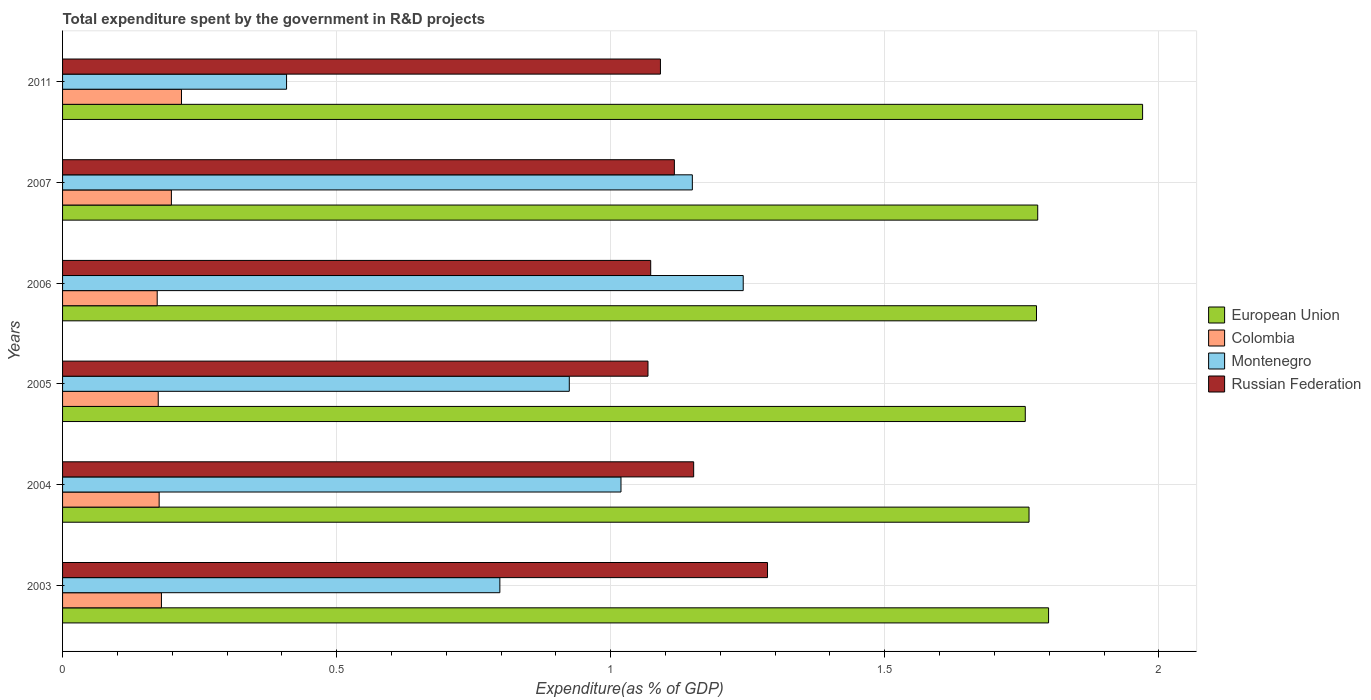How many groups of bars are there?
Keep it short and to the point. 6. Are the number of bars per tick equal to the number of legend labels?
Ensure brevity in your answer.  Yes. Are the number of bars on each tick of the Y-axis equal?
Provide a short and direct response. Yes. How many bars are there on the 6th tick from the top?
Offer a very short reply. 4. How many bars are there on the 3rd tick from the bottom?
Keep it short and to the point. 4. What is the label of the 5th group of bars from the top?
Your answer should be compact. 2004. In how many cases, is the number of bars for a given year not equal to the number of legend labels?
Provide a succinct answer. 0. What is the total expenditure spent by the government in R&D projects in Colombia in 2004?
Provide a succinct answer. 0.18. Across all years, what is the maximum total expenditure spent by the government in R&D projects in Montenegro?
Offer a very short reply. 1.24. Across all years, what is the minimum total expenditure spent by the government in R&D projects in Colombia?
Ensure brevity in your answer.  0.17. In which year was the total expenditure spent by the government in R&D projects in Montenegro maximum?
Give a very brief answer. 2006. In which year was the total expenditure spent by the government in R&D projects in Colombia minimum?
Provide a succinct answer. 2006. What is the total total expenditure spent by the government in R&D projects in Montenegro in the graph?
Your answer should be very brief. 5.54. What is the difference between the total expenditure spent by the government in R&D projects in Montenegro in 2007 and that in 2011?
Ensure brevity in your answer.  0.74. What is the difference between the total expenditure spent by the government in R&D projects in Montenegro in 2007 and the total expenditure spent by the government in R&D projects in European Union in 2003?
Ensure brevity in your answer.  -0.65. What is the average total expenditure spent by the government in R&D projects in Russian Federation per year?
Provide a short and direct response. 1.13. In the year 2005, what is the difference between the total expenditure spent by the government in R&D projects in European Union and total expenditure spent by the government in R&D projects in Russian Federation?
Keep it short and to the point. 0.69. In how many years, is the total expenditure spent by the government in R&D projects in European Union greater than 0.30000000000000004 %?
Make the answer very short. 6. What is the ratio of the total expenditure spent by the government in R&D projects in Colombia in 2005 to that in 2011?
Your response must be concise. 0.8. What is the difference between the highest and the second highest total expenditure spent by the government in R&D projects in Russian Federation?
Offer a terse response. 0.13. What is the difference between the highest and the lowest total expenditure spent by the government in R&D projects in Russian Federation?
Offer a terse response. 0.22. In how many years, is the total expenditure spent by the government in R&D projects in Russian Federation greater than the average total expenditure spent by the government in R&D projects in Russian Federation taken over all years?
Give a very brief answer. 2. Is it the case that in every year, the sum of the total expenditure spent by the government in R&D projects in Colombia and total expenditure spent by the government in R&D projects in European Union is greater than the sum of total expenditure spent by the government in R&D projects in Russian Federation and total expenditure spent by the government in R&D projects in Montenegro?
Ensure brevity in your answer.  No. What does the 1st bar from the top in 2005 represents?
Make the answer very short. Russian Federation. How many bars are there?
Offer a very short reply. 24. How many years are there in the graph?
Make the answer very short. 6. Does the graph contain grids?
Your answer should be very brief. Yes. What is the title of the graph?
Keep it short and to the point. Total expenditure spent by the government in R&D projects. Does "High income" appear as one of the legend labels in the graph?
Your answer should be compact. No. What is the label or title of the X-axis?
Make the answer very short. Expenditure(as % of GDP). What is the label or title of the Y-axis?
Keep it short and to the point. Years. What is the Expenditure(as % of GDP) in European Union in 2003?
Make the answer very short. 1.8. What is the Expenditure(as % of GDP) in Colombia in 2003?
Your answer should be compact. 0.18. What is the Expenditure(as % of GDP) of Montenegro in 2003?
Provide a succinct answer. 0.8. What is the Expenditure(as % of GDP) of Russian Federation in 2003?
Offer a terse response. 1.29. What is the Expenditure(as % of GDP) of European Union in 2004?
Offer a terse response. 1.76. What is the Expenditure(as % of GDP) of Colombia in 2004?
Your answer should be compact. 0.18. What is the Expenditure(as % of GDP) of Montenegro in 2004?
Make the answer very short. 1.02. What is the Expenditure(as % of GDP) in Russian Federation in 2004?
Your answer should be very brief. 1.15. What is the Expenditure(as % of GDP) of European Union in 2005?
Your answer should be very brief. 1.76. What is the Expenditure(as % of GDP) of Colombia in 2005?
Make the answer very short. 0.17. What is the Expenditure(as % of GDP) in Montenegro in 2005?
Give a very brief answer. 0.92. What is the Expenditure(as % of GDP) in Russian Federation in 2005?
Make the answer very short. 1.07. What is the Expenditure(as % of GDP) of European Union in 2006?
Your response must be concise. 1.78. What is the Expenditure(as % of GDP) in Colombia in 2006?
Give a very brief answer. 0.17. What is the Expenditure(as % of GDP) in Montenegro in 2006?
Give a very brief answer. 1.24. What is the Expenditure(as % of GDP) in Russian Federation in 2006?
Your answer should be very brief. 1.07. What is the Expenditure(as % of GDP) in European Union in 2007?
Your response must be concise. 1.78. What is the Expenditure(as % of GDP) of Colombia in 2007?
Provide a succinct answer. 0.2. What is the Expenditure(as % of GDP) of Montenegro in 2007?
Your answer should be compact. 1.15. What is the Expenditure(as % of GDP) in Russian Federation in 2007?
Your answer should be compact. 1.12. What is the Expenditure(as % of GDP) of European Union in 2011?
Your answer should be very brief. 1.97. What is the Expenditure(as % of GDP) in Colombia in 2011?
Provide a succinct answer. 0.22. What is the Expenditure(as % of GDP) of Montenegro in 2011?
Ensure brevity in your answer.  0.41. What is the Expenditure(as % of GDP) of Russian Federation in 2011?
Your response must be concise. 1.09. Across all years, what is the maximum Expenditure(as % of GDP) in European Union?
Give a very brief answer. 1.97. Across all years, what is the maximum Expenditure(as % of GDP) of Colombia?
Make the answer very short. 0.22. Across all years, what is the maximum Expenditure(as % of GDP) in Montenegro?
Provide a short and direct response. 1.24. Across all years, what is the maximum Expenditure(as % of GDP) of Russian Federation?
Keep it short and to the point. 1.29. Across all years, what is the minimum Expenditure(as % of GDP) in European Union?
Provide a short and direct response. 1.76. Across all years, what is the minimum Expenditure(as % of GDP) in Colombia?
Provide a short and direct response. 0.17. Across all years, what is the minimum Expenditure(as % of GDP) of Montenegro?
Provide a short and direct response. 0.41. Across all years, what is the minimum Expenditure(as % of GDP) of Russian Federation?
Provide a short and direct response. 1.07. What is the total Expenditure(as % of GDP) in European Union in the graph?
Provide a succinct answer. 10.84. What is the total Expenditure(as % of GDP) in Colombia in the graph?
Your answer should be very brief. 1.12. What is the total Expenditure(as % of GDP) in Montenegro in the graph?
Keep it short and to the point. 5.54. What is the total Expenditure(as % of GDP) in Russian Federation in the graph?
Your answer should be compact. 6.79. What is the difference between the Expenditure(as % of GDP) in European Union in 2003 and that in 2004?
Provide a succinct answer. 0.04. What is the difference between the Expenditure(as % of GDP) in Colombia in 2003 and that in 2004?
Offer a very short reply. 0. What is the difference between the Expenditure(as % of GDP) in Montenegro in 2003 and that in 2004?
Your answer should be compact. -0.22. What is the difference between the Expenditure(as % of GDP) in Russian Federation in 2003 and that in 2004?
Your response must be concise. 0.13. What is the difference between the Expenditure(as % of GDP) in European Union in 2003 and that in 2005?
Provide a short and direct response. 0.04. What is the difference between the Expenditure(as % of GDP) in Colombia in 2003 and that in 2005?
Provide a succinct answer. 0.01. What is the difference between the Expenditure(as % of GDP) in Montenegro in 2003 and that in 2005?
Keep it short and to the point. -0.13. What is the difference between the Expenditure(as % of GDP) of Russian Federation in 2003 and that in 2005?
Your answer should be compact. 0.22. What is the difference between the Expenditure(as % of GDP) in European Union in 2003 and that in 2006?
Your answer should be very brief. 0.02. What is the difference between the Expenditure(as % of GDP) of Colombia in 2003 and that in 2006?
Provide a short and direct response. 0.01. What is the difference between the Expenditure(as % of GDP) of Montenegro in 2003 and that in 2006?
Offer a terse response. -0.44. What is the difference between the Expenditure(as % of GDP) in Russian Federation in 2003 and that in 2006?
Your answer should be compact. 0.21. What is the difference between the Expenditure(as % of GDP) in European Union in 2003 and that in 2007?
Keep it short and to the point. 0.02. What is the difference between the Expenditure(as % of GDP) of Colombia in 2003 and that in 2007?
Give a very brief answer. -0.02. What is the difference between the Expenditure(as % of GDP) in Montenegro in 2003 and that in 2007?
Your answer should be very brief. -0.35. What is the difference between the Expenditure(as % of GDP) in Russian Federation in 2003 and that in 2007?
Make the answer very short. 0.17. What is the difference between the Expenditure(as % of GDP) of European Union in 2003 and that in 2011?
Provide a short and direct response. -0.17. What is the difference between the Expenditure(as % of GDP) of Colombia in 2003 and that in 2011?
Your response must be concise. -0.04. What is the difference between the Expenditure(as % of GDP) of Montenegro in 2003 and that in 2011?
Provide a succinct answer. 0.39. What is the difference between the Expenditure(as % of GDP) of Russian Federation in 2003 and that in 2011?
Your response must be concise. 0.2. What is the difference between the Expenditure(as % of GDP) in European Union in 2004 and that in 2005?
Your answer should be very brief. 0.01. What is the difference between the Expenditure(as % of GDP) of Colombia in 2004 and that in 2005?
Provide a succinct answer. 0. What is the difference between the Expenditure(as % of GDP) of Montenegro in 2004 and that in 2005?
Ensure brevity in your answer.  0.09. What is the difference between the Expenditure(as % of GDP) of Russian Federation in 2004 and that in 2005?
Give a very brief answer. 0.08. What is the difference between the Expenditure(as % of GDP) of European Union in 2004 and that in 2006?
Provide a short and direct response. -0.01. What is the difference between the Expenditure(as % of GDP) in Colombia in 2004 and that in 2006?
Make the answer very short. 0. What is the difference between the Expenditure(as % of GDP) in Montenegro in 2004 and that in 2006?
Make the answer very short. -0.22. What is the difference between the Expenditure(as % of GDP) in Russian Federation in 2004 and that in 2006?
Your response must be concise. 0.08. What is the difference between the Expenditure(as % of GDP) of European Union in 2004 and that in 2007?
Provide a succinct answer. -0.02. What is the difference between the Expenditure(as % of GDP) of Colombia in 2004 and that in 2007?
Ensure brevity in your answer.  -0.02. What is the difference between the Expenditure(as % of GDP) in Montenegro in 2004 and that in 2007?
Make the answer very short. -0.13. What is the difference between the Expenditure(as % of GDP) in Russian Federation in 2004 and that in 2007?
Ensure brevity in your answer.  0.04. What is the difference between the Expenditure(as % of GDP) of European Union in 2004 and that in 2011?
Provide a short and direct response. -0.21. What is the difference between the Expenditure(as % of GDP) of Colombia in 2004 and that in 2011?
Keep it short and to the point. -0.04. What is the difference between the Expenditure(as % of GDP) in Montenegro in 2004 and that in 2011?
Ensure brevity in your answer.  0.61. What is the difference between the Expenditure(as % of GDP) in Russian Federation in 2004 and that in 2011?
Keep it short and to the point. 0.06. What is the difference between the Expenditure(as % of GDP) of European Union in 2005 and that in 2006?
Give a very brief answer. -0.02. What is the difference between the Expenditure(as % of GDP) in Colombia in 2005 and that in 2006?
Provide a short and direct response. 0. What is the difference between the Expenditure(as % of GDP) of Montenegro in 2005 and that in 2006?
Offer a very short reply. -0.32. What is the difference between the Expenditure(as % of GDP) of Russian Federation in 2005 and that in 2006?
Your response must be concise. -0.01. What is the difference between the Expenditure(as % of GDP) of European Union in 2005 and that in 2007?
Your answer should be very brief. -0.02. What is the difference between the Expenditure(as % of GDP) in Colombia in 2005 and that in 2007?
Provide a short and direct response. -0.02. What is the difference between the Expenditure(as % of GDP) in Montenegro in 2005 and that in 2007?
Offer a terse response. -0.22. What is the difference between the Expenditure(as % of GDP) in Russian Federation in 2005 and that in 2007?
Offer a terse response. -0.05. What is the difference between the Expenditure(as % of GDP) of European Union in 2005 and that in 2011?
Make the answer very short. -0.21. What is the difference between the Expenditure(as % of GDP) in Colombia in 2005 and that in 2011?
Provide a succinct answer. -0.04. What is the difference between the Expenditure(as % of GDP) in Montenegro in 2005 and that in 2011?
Offer a terse response. 0.52. What is the difference between the Expenditure(as % of GDP) of Russian Federation in 2005 and that in 2011?
Your answer should be compact. -0.02. What is the difference between the Expenditure(as % of GDP) of European Union in 2006 and that in 2007?
Offer a terse response. -0. What is the difference between the Expenditure(as % of GDP) in Colombia in 2006 and that in 2007?
Provide a succinct answer. -0.03. What is the difference between the Expenditure(as % of GDP) of Montenegro in 2006 and that in 2007?
Provide a short and direct response. 0.09. What is the difference between the Expenditure(as % of GDP) of Russian Federation in 2006 and that in 2007?
Make the answer very short. -0.04. What is the difference between the Expenditure(as % of GDP) in European Union in 2006 and that in 2011?
Give a very brief answer. -0.19. What is the difference between the Expenditure(as % of GDP) of Colombia in 2006 and that in 2011?
Give a very brief answer. -0.04. What is the difference between the Expenditure(as % of GDP) of Montenegro in 2006 and that in 2011?
Ensure brevity in your answer.  0.83. What is the difference between the Expenditure(as % of GDP) in Russian Federation in 2006 and that in 2011?
Give a very brief answer. -0.02. What is the difference between the Expenditure(as % of GDP) in European Union in 2007 and that in 2011?
Your answer should be compact. -0.19. What is the difference between the Expenditure(as % of GDP) of Colombia in 2007 and that in 2011?
Keep it short and to the point. -0.02. What is the difference between the Expenditure(as % of GDP) in Montenegro in 2007 and that in 2011?
Ensure brevity in your answer.  0.74. What is the difference between the Expenditure(as % of GDP) of Russian Federation in 2007 and that in 2011?
Provide a short and direct response. 0.03. What is the difference between the Expenditure(as % of GDP) of European Union in 2003 and the Expenditure(as % of GDP) of Colombia in 2004?
Offer a very short reply. 1.62. What is the difference between the Expenditure(as % of GDP) of European Union in 2003 and the Expenditure(as % of GDP) of Montenegro in 2004?
Your response must be concise. 0.78. What is the difference between the Expenditure(as % of GDP) in European Union in 2003 and the Expenditure(as % of GDP) in Russian Federation in 2004?
Keep it short and to the point. 0.65. What is the difference between the Expenditure(as % of GDP) in Colombia in 2003 and the Expenditure(as % of GDP) in Montenegro in 2004?
Keep it short and to the point. -0.84. What is the difference between the Expenditure(as % of GDP) of Colombia in 2003 and the Expenditure(as % of GDP) of Russian Federation in 2004?
Ensure brevity in your answer.  -0.97. What is the difference between the Expenditure(as % of GDP) of Montenegro in 2003 and the Expenditure(as % of GDP) of Russian Federation in 2004?
Ensure brevity in your answer.  -0.35. What is the difference between the Expenditure(as % of GDP) in European Union in 2003 and the Expenditure(as % of GDP) in Colombia in 2005?
Provide a short and direct response. 1.62. What is the difference between the Expenditure(as % of GDP) of European Union in 2003 and the Expenditure(as % of GDP) of Montenegro in 2005?
Your answer should be compact. 0.87. What is the difference between the Expenditure(as % of GDP) of European Union in 2003 and the Expenditure(as % of GDP) of Russian Federation in 2005?
Provide a short and direct response. 0.73. What is the difference between the Expenditure(as % of GDP) in Colombia in 2003 and the Expenditure(as % of GDP) in Montenegro in 2005?
Offer a terse response. -0.74. What is the difference between the Expenditure(as % of GDP) of Colombia in 2003 and the Expenditure(as % of GDP) of Russian Federation in 2005?
Offer a terse response. -0.89. What is the difference between the Expenditure(as % of GDP) of Montenegro in 2003 and the Expenditure(as % of GDP) of Russian Federation in 2005?
Offer a terse response. -0.27. What is the difference between the Expenditure(as % of GDP) in European Union in 2003 and the Expenditure(as % of GDP) in Colombia in 2006?
Offer a terse response. 1.63. What is the difference between the Expenditure(as % of GDP) of European Union in 2003 and the Expenditure(as % of GDP) of Montenegro in 2006?
Provide a succinct answer. 0.56. What is the difference between the Expenditure(as % of GDP) in European Union in 2003 and the Expenditure(as % of GDP) in Russian Federation in 2006?
Your answer should be very brief. 0.73. What is the difference between the Expenditure(as % of GDP) in Colombia in 2003 and the Expenditure(as % of GDP) in Montenegro in 2006?
Your response must be concise. -1.06. What is the difference between the Expenditure(as % of GDP) in Colombia in 2003 and the Expenditure(as % of GDP) in Russian Federation in 2006?
Ensure brevity in your answer.  -0.89. What is the difference between the Expenditure(as % of GDP) of Montenegro in 2003 and the Expenditure(as % of GDP) of Russian Federation in 2006?
Offer a very short reply. -0.28. What is the difference between the Expenditure(as % of GDP) in European Union in 2003 and the Expenditure(as % of GDP) in Colombia in 2007?
Offer a terse response. 1.6. What is the difference between the Expenditure(as % of GDP) of European Union in 2003 and the Expenditure(as % of GDP) of Montenegro in 2007?
Your answer should be very brief. 0.65. What is the difference between the Expenditure(as % of GDP) of European Union in 2003 and the Expenditure(as % of GDP) of Russian Federation in 2007?
Your answer should be very brief. 0.68. What is the difference between the Expenditure(as % of GDP) of Colombia in 2003 and the Expenditure(as % of GDP) of Montenegro in 2007?
Give a very brief answer. -0.97. What is the difference between the Expenditure(as % of GDP) in Colombia in 2003 and the Expenditure(as % of GDP) in Russian Federation in 2007?
Ensure brevity in your answer.  -0.94. What is the difference between the Expenditure(as % of GDP) of Montenegro in 2003 and the Expenditure(as % of GDP) of Russian Federation in 2007?
Offer a terse response. -0.32. What is the difference between the Expenditure(as % of GDP) of European Union in 2003 and the Expenditure(as % of GDP) of Colombia in 2011?
Provide a short and direct response. 1.58. What is the difference between the Expenditure(as % of GDP) in European Union in 2003 and the Expenditure(as % of GDP) in Montenegro in 2011?
Give a very brief answer. 1.39. What is the difference between the Expenditure(as % of GDP) in European Union in 2003 and the Expenditure(as % of GDP) in Russian Federation in 2011?
Keep it short and to the point. 0.71. What is the difference between the Expenditure(as % of GDP) of Colombia in 2003 and the Expenditure(as % of GDP) of Montenegro in 2011?
Give a very brief answer. -0.23. What is the difference between the Expenditure(as % of GDP) in Colombia in 2003 and the Expenditure(as % of GDP) in Russian Federation in 2011?
Provide a short and direct response. -0.91. What is the difference between the Expenditure(as % of GDP) in Montenegro in 2003 and the Expenditure(as % of GDP) in Russian Federation in 2011?
Provide a succinct answer. -0.29. What is the difference between the Expenditure(as % of GDP) of European Union in 2004 and the Expenditure(as % of GDP) of Colombia in 2005?
Provide a short and direct response. 1.59. What is the difference between the Expenditure(as % of GDP) of European Union in 2004 and the Expenditure(as % of GDP) of Montenegro in 2005?
Provide a succinct answer. 0.84. What is the difference between the Expenditure(as % of GDP) in European Union in 2004 and the Expenditure(as % of GDP) in Russian Federation in 2005?
Your answer should be very brief. 0.7. What is the difference between the Expenditure(as % of GDP) in Colombia in 2004 and the Expenditure(as % of GDP) in Montenegro in 2005?
Your response must be concise. -0.75. What is the difference between the Expenditure(as % of GDP) of Colombia in 2004 and the Expenditure(as % of GDP) of Russian Federation in 2005?
Provide a short and direct response. -0.89. What is the difference between the Expenditure(as % of GDP) in Montenegro in 2004 and the Expenditure(as % of GDP) in Russian Federation in 2005?
Your answer should be very brief. -0.05. What is the difference between the Expenditure(as % of GDP) of European Union in 2004 and the Expenditure(as % of GDP) of Colombia in 2006?
Your answer should be very brief. 1.59. What is the difference between the Expenditure(as % of GDP) of European Union in 2004 and the Expenditure(as % of GDP) of Montenegro in 2006?
Make the answer very short. 0.52. What is the difference between the Expenditure(as % of GDP) in European Union in 2004 and the Expenditure(as % of GDP) in Russian Federation in 2006?
Offer a very short reply. 0.69. What is the difference between the Expenditure(as % of GDP) in Colombia in 2004 and the Expenditure(as % of GDP) in Montenegro in 2006?
Ensure brevity in your answer.  -1.07. What is the difference between the Expenditure(as % of GDP) in Colombia in 2004 and the Expenditure(as % of GDP) in Russian Federation in 2006?
Provide a succinct answer. -0.9. What is the difference between the Expenditure(as % of GDP) of Montenegro in 2004 and the Expenditure(as % of GDP) of Russian Federation in 2006?
Your response must be concise. -0.05. What is the difference between the Expenditure(as % of GDP) of European Union in 2004 and the Expenditure(as % of GDP) of Colombia in 2007?
Give a very brief answer. 1.56. What is the difference between the Expenditure(as % of GDP) in European Union in 2004 and the Expenditure(as % of GDP) in Montenegro in 2007?
Your response must be concise. 0.61. What is the difference between the Expenditure(as % of GDP) of European Union in 2004 and the Expenditure(as % of GDP) of Russian Federation in 2007?
Make the answer very short. 0.65. What is the difference between the Expenditure(as % of GDP) in Colombia in 2004 and the Expenditure(as % of GDP) in Montenegro in 2007?
Provide a short and direct response. -0.97. What is the difference between the Expenditure(as % of GDP) of Colombia in 2004 and the Expenditure(as % of GDP) of Russian Federation in 2007?
Provide a succinct answer. -0.94. What is the difference between the Expenditure(as % of GDP) in Montenegro in 2004 and the Expenditure(as % of GDP) in Russian Federation in 2007?
Offer a very short reply. -0.1. What is the difference between the Expenditure(as % of GDP) in European Union in 2004 and the Expenditure(as % of GDP) in Colombia in 2011?
Your answer should be very brief. 1.55. What is the difference between the Expenditure(as % of GDP) of European Union in 2004 and the Expenditure(as % of GDP) of Montenegro in 2011?
Offer a terse response. 1.35. What is the difference between the Expenditure(as % of GDP) in European Union in 2004 and the Expenditure(as % of GDP) in Russian Federation in 2011?
Provide a short and direct response. 0.67. What is the difference between the Expenditure(as % of GDP) in Colombia in 2004 and the Expenditure(as % of GDP) in Montenegro in 2011?
Your answer should be very brief. -0.23. What is the difference between the Expenditure(as % of GDP) in Colombia in 2004 and the Expenditure(as % of GDP) in Russian Federation in 2011?
Your answer should be compact. -0.91. What is the difference between the Expenditure(as % of GDP) in Montenegro in 2004 and the Expenditure(as % of GDP) in Russian Federation in 2011?
Your response must be concise. -0.07. What is the difference between the Expenditure(as % of GDP) in European Union in 2005 and the Expenditure(as % of GDP) in Colombia in 2006?
Offer a terse response. 1.58. What is the difference between the Expenditure(as % of GDP) of European Union in 2005 and the Expenditure(as % of GDP) of Montenegro in 2006?
Ensure brevity in your answer.  0.51. What is the difference between the Expenditure(as % of GDP) of European Union in 2005 and the Expenditure(as % of GDP) of Russian Federation in 2006?
Your answer should be compact. 0.68. What is the difference between the Expenditure(as % of GDP) of Colombia in 2005 and the Expenditure(as % of GDP) of Montenegro in 2006?
Offer a very short reply. -1.07. What is the difference between the Expenditure(as % of GDP) in Colombia in 2005 and the Expenditure(as % of GDP) in Russian Federation in 2006?
Your response must be concise. -0.9. What is the difference between the Expenditure(as % of GDP) of Montenegro in 2005 and the Expenditure(as % of GDP) of Russian Federation in 2006?
Give a very brief answer. -0.15. What is the difference between the Expenditure(as % of GDP) in European Union in 2005 and the Expenditure(as % of GDP) in Colombia in 2007?
Your answer should be very brief. 1.56. What is the difference between the Expenditure(as % of GDP) of European Union in 2005 and the Expenditure(as % of GDP) of Montenegro in 2007?
Your response must be concise. 0.61. What is the difference between the Expenditure(as % of GDP) of European Union in 2005 and the Expenditure(as % of GDP) of Russian Federation in 2007?
Your answer should be very brief. 0.64. What is the difference between the Expenditure(as % of GDP) of Colombia in 2005 and the Expenditure(as % of GDP) of Montenegro in 2007?
Make the answer very short. -0.97. What is the difference between the Expenditure(as % of GDP) of Colombia in 2005 and the Expenditure(as % of GDP) of Russian Federation in 2007?
Ensure brevity in your answer.  -0.94. What is the difference between the Expenditure(as % of GDP) in Montenegro in 2005 and the Expenditure(as % of GDP) in Russian Federation in 2007?
Your answer should be very brief. -0.19. What is the difference between the Expenditure(as % of GDP) in European Union in 2005 and the Expenditure(as % of GDP) in Colombia in 2011?
Your answer should be very brief. 1.54. What is the difference between the Expenditure(as % of GDP) in European Union in 2005 and the Expenditure(as % of GDP) in Montenegro in 2011?
Ensure brevity in your answer.  1.35. What is the difference between the Expenditure(as % of GDP) in European Union in 2005 and the Expenditure(as % of GDP) in Russian Federation in 2011?
Keep it short and to the point. 0.67. What is the difference between the Expenditure(as % of GDP) of Colombia in 2005 and the Expenditure(as % of GDP) of Montenegro in 2011?
Offer a very short reply. -0.23. What is the difference between the Expenditure(as % of GDP) of Colombia in 2005 and the Expenditure(as % of GDP) of Russian Federation in 2011?
Ensure brevity in your answer.  -0.92. What is the difference between the Expenditure(as % of GDP) in Montenegro in 2005 and the Expenditure(as % of GDP) in Russian Federation in 2011?
Your answer should be very brief. -0.17. What is the difference between the Expenditure(as % of GDP) in European Union in 2006 and the Expenditure(as % of GDP) in Colombia in 2007?
Keep it short and to the point. 1.58. What is the difference between the Expenditure(as % of GDP) in European Union in 2006 and the Expenditure(as % of GDP) in Montenegro in 2007?
Provide a succinct answer. 0.63. What is the difference between the Expenditure(as % of GDP) of European Union in 2006 and the Expenditure(as % of GDP) of Russian Federation in 2007?
Offer a very short reply. 0.66. What is the difference between the Expenditure(as % of GDP) in Colombia in 2006 and the Expenditure(as % of GDP) in Montenegro in 2007?
Provide a succinct answer. -0.98. What is the difference between the Expenditure(as % of GDP) in Colombia in 2006 and the Expenditure(as % of GDP) in Russian Federation in 2007?
Your answer should be compact. -0.94. What is the difference between the Expenditure(as % of GDP) of Montenegro in 2006 and the Expenditure(as % of GDP) of Russian Federation in 2007?
Your answer should be very brief. 0.13. What is the difference between the Expenditure(as % of GDP) in European Union in 2006 and the Expenditure(as % of GDP) in Colombia in 2011?
Provide a short and direct response. 1.56. What is the difference between the Expenditure(as % of GDP) of European Union in 2006 and the Expenditure(as % of GDP) of Montenegro in 2011?
Provide a succinct answer. 1.37. What is the difference between the Expenditure(as % of GDP) in European Union in 2006 and the Expenditure(as % of GDP) in Russian Federation in 2011?
Keep it short and to the point. 0.69. What is the difference between the Expenditure(as % of GDP) of Colombia in 2006 and the Expenditure(as % of GDP) of Montenegro in 2011?
Ensure brevity in your answer.  -0.24. What is the difference between the Expenditure(as % of GDP) in Colombia in 2006 and the Expenditure(as % of GDP) in Russian Federation in 2011?
Your answer should be compact. -0.92. What is the difference between the Expenditure(as % of GDP) of Montenegro in 2006 and the Expenditure(as % of GDP) of Russian Federation in 2011?
Provide a succinct answer. 0.15. What is the difference between the Expenditure(as % of GDP) in European Union in 2007 and the Expenditure(as % of GDP) in Colombia in 2011?
Ensure brevity in your answer.  1.56. What is the difference between the Expenditure(as % of GDP) of European Union in 2007 and the Expenditure(as % of GDP) of Montenegro in 2011?
Make the answer very short. 1.37. What is the difference between the Expenditure(as % of GDP) of European Union in 2007 and the Expenditure(as % of GDP) of Russian Federation in 2011?
Provide a succinct answer. 0.69. What is the difference between the Expenditure(as % of GDP) in Colombia in 2007 and the Expenditure(as % of GDP) in Montenegro in 2011?
Your answer should be compact. -0.21. What is the difference between the Expenditure(as % of GDP) in Colombia in 2007 and the Expenditure(as % of GDP) in Russian Federation in 2011?
Provide a succinct answer. -0.89. What is the difference between the Expenditure(as % of GDP) in Montenegro in 2007 and the Expenditure(as % of GDP) in Russian Federation in 2011?
Your answer should be compact. 0.06. What is the average Expenditure(as % of GDP) in European Union per year?
Ensure brevity in your answer.  1.81. What is the average Expenditure(as % of GDP) in Colombia per year?
Provide a succinct answer. 0.19. What is the average Expenditure(as % of GDP) of Montenegro per year?
Offer a very short reply. 0.92. What is the average Expenditure(as % of GDP) in Russian Federation per year?
Make the answer very short. 1.13. In the year 2003, what is the difference between the Expenditure(as % of GDP) in European Union and Expenditure(as % of GDP) in Colombia?
Your response must be concise. 1.62. In the year 2003, what is the difference between the Expenditure(as % of GDP) of European Union and Expenditure(as % of GDP) of Montenegro?
Provide a short and direct response. 1. In the year 2003, what is the difference between the Expenditure(as % of GDP) of European Union and Expenditure(as % of GDP) of Russian Federation?
Your response must be concise. 0.51. In the year 2003, what is the difference between the Expenditure(as % of GDP) in Colombia and Expenditure(as % of GDP) in Montenegro?
Make the answer very short. -0.62. In the year 2003, what is the difference between the Expenditure(as % of GDP) in Colombia and Expenditure(as % of GDP) in Russian Federation?
Offer a terse response. -1.11. In the year 2003, what is the difference between the Expenditure(as % of GDP) of Montenegro and Expenditure(as % of GDP) of Russian Federation?
Your answer should be compact. -0.49. In the year 2004, what is the difference between the Expenditure(as % of GDP) of European Union and Expenditure(as % of GDP) of Colombia?
Offer a terse response. 1.59. In the year 2004, what is the difference between the Expenditure(as % of GDP) of European Union and Expenditure(as % of GDP) of Montenegro?
Your answer should be compact. 0.74. In the year 2004, what is the difference between the Expenditure(as % of GDP) in European Union and Expenditure(as % of GDP) in Russian Federation?
Offer a terse response. 0.61. In the year 2004, what is the difference between the Expenditure(as % of GDP) of Colombia and Expenditure(as % of GDP) of Montenegro?
Your answer should be compact. -0.84. In the year 2004, what is the difference between the Expenditure(as % of GDP) in Colombia and Expenditure(as % of GDP) in Russian Federation?
Offer a very short reply. -0.98. In the year 2004, what is the difference between the Expenditure(as % of GDP) of Montenegro and Expenditure(as % of GDP) of Russian Federation?
Your answer should be very brief. -0.13. In the year 2005, what is the difference between the Expenditure(as % of GDP) in European Union and Expenditure(as % of GDP) in Colombia?
Offer a very short reply. 1.58. In the year 2005, what is the difference between the Expenditure(as % of GDP) in European Union and Expenditure(as % of GDP) in Montenegro?
Provide a succinct answer. 0.83. In the year 2005, what is the difference between the Expenditure(as % of GDP) of European Union and Expenditure(as % of GDP) of Russian Federation?
Keep it short and to the point. 0.69. In the year 2005, what is the difference between the Expenditure(as % of GDP) of Colombia and Expenditure(as % of GDP) of Montenegro?
Your response must be concise. -0.75. In the year 2005, what is the difference between the Expenditure(as % of GDP) in Colombia and Expenditure(as % of GDP) in Russian Federation?
Provide a succinct answer. -0.89. In the year 2005, what is the difference between the Expenditure(as % of GDP) in Montenegro and Expenditure(as % of GDP) in Russian Federation?
Provide a succinct answer. -0.14. In the year 2006, what is the difference between the Expenditure(as % of GDP) of European Union and Expenditure(as % of GDP) of Colombia?
Provide a short and direct response. 1.6. In the year 2006, what is the difference between the Expenditure(as % of GDP) of European Union and Expenditure(as % of GDP) of Montenegro?
Give a very brief answer. 0.54. In the year 2006, what is the difference between the Expenditure(as % of GDP) in European Union and Expenditure(as % of GDP) in Russian Federation?
Offer a very short reply. 0.7. In the year 2006, what is the difference between the Expenditure(as % of GDP) in Colombia and Expenditure(as % of GDP) in Montenegro?
Keep it short and to the point. -1.07. In the year 2006, what is the difference between the Expenditure(as % of GDP) of Colombia and Expenditure(as % of GDP) of Russian Federation?
Your response must be concise. -0.9. In the year 2006, what is the difference between the Expenditure(as % of GDP) in Montenegro and Expenditure(as % of GDP) in Russian Federation?
Provide a short and direct response. 0.17. In the year 2007, what is the difference between the Expenditure(as % of GDP) of European Union and Expenditure(as % of GDP) of Colombia?
Keep it short and to the point. 1.58. In the year 2007, what is the difference between the Expenditure(as % of GDP) of European Union and Expenditure(as % of GDP) of Montenegro?
Offer a terse response. 0.63. In the year 2007, what is the difference between the Expenditure(as % of GDP) of European Union and Expenditure(as % of GDP) of Russian Federation?
Your answer should be very brief. 0.66. In the year 2007, what is the difference between the Expenditure(as % of GDP) of Colombia and Expenditure(as % of GDP) of Montenegro?
Your answer should be very brief. -0.95. In the year 2007, what is the difference between the Expenditure(as % of GDP) in Colombia and Expenditure(as % of GDP) in Russian Federation?
Provide a succinct answer. -0.92. In the year 2007, what is the difference between the Expenditure(as % of GDP) in Montenegro and Expenditure(as % of GDP) in Russian Federation?
Make the answer very short. 0.03. In the year 2011, what is the difference between the Expenditure(as % of GDP) in European Union and Expenditure(as % of GDP) in Colombia?
Your response must be concise. 1.75. In the year 2011, what is the difference between the Expenditure(as % of GDP) of European Union and Expenditure(as % of GDP) of Montenegro?
Offer a terse response. 1.56. In the year 2011, what is the difference between the Expenditure(as % of GDP) of European Union and Expenditure(as % of GDP) of Russian Federation?
Offer a very short reply. 0.88. In the year 2011, what is the difference between the Expenditure(as % of GDP) of Colombia and Expenditure(as % of GDP) of Montenegro?
Your answer should be compact. -0.19. In the year 2011, what is the difference between the Expenditure(as % of GDP) in Colombia and Expenditure(as % of GDP) in Russian Federation?
Keep it short and to the point. -0.87. In the year 2011, what is the difference between the Expenditure(as % of GDP) in Montenegro and Expenditure(as % of GDP) in Russian Federation?
Keep it short and to the point. -0.68. What is the ratio of the Expenditure(as % of GDP) in European Union in 2003 to that in 2004?
Provide a short and direct response. 1.02. What is the ratio of the Expenditure(as % of GDP) in Colombia in 2003 to that in 2004?
Ensure brevity in your answer.  1.02. What is the ratio of the Expenditure(as % of GDP) of Montenegro in 2003 to that in 2004?
Your response must be concise. 0.78. What is the ratio of the Expenditure(as % of GDP) in Russian Federation in 2003 to that in 2004?
Provide a succinct answer. 1.12. What is the ratio of the Expenditure(as % of GDP) of European Union in 2003 to that in 2005?
Provide a short and direct response. 1.02. What is the ratio of the Expenditure(as % of GDP) of Colombia in 2003 to that in 2005?
Give a very brief answer. 1.03. What is the ratio of the Expenditure(as % of GDP) in Montenegro in 2003 to that in 2005?
Make the answer very short. 0.86. What is the ratio of the Expenditure(as % of GDP) in Russian Federation in 2003 to that in 2005?
Offer a very short reply. 1.2. What is the ratio of the Expenditure(as % of GDP) in European Union in 2003 to that in 2006?
Ensure brevity in your answer.  1.01. What is the ratio of the Expenditure(as % of GDP) of Colombia in 2003 to that in 2006?
Provide a succinct answer. 1.04. What is the ratio of the Expenditure(as % of GDP) in Montenegro in 2003 to that in 2006?
Keep it short and to the point. 0.64. What is the ratio of the Expenditure(as % of GDP) of Russian Federation in 2003 to that in 2006?
Your answer should be compact. 1.2. What is the ratio of the Expenditure(as % of GDP) in European Union in 2003 to that in 2007?
Provide a succinct answer. 1.01. What is the ratio of the Expenditure(as % of GDP) in Colombia in 2003 to that in 2007?
Give a very brief answer. 0.91. What is the ratio of the Expenditure(as % of GDP) of Montenegro in 2003 to that in 2007?
Keep it short and to the point. 0.69. What is the ratio of the Expenditure(as % of GDP) in Russian Federation in 2003 to that in 2007?
Your answer should be compact. 1.15. What is the ratio of the Expenditure(as % of GDP) of European Union in 2003 to that in 2011?
Your answer should be very brief. 0.91. What is the ratio of the Expenditure(as % of GDP) of Colombia in 2003 to that in 2011?
Your response must be concise. 0.83. What is the ratio of the Expenditure(as % of GDP) of Montenegro in 2003 to that in 2011?
Ensure brevity in your answer.  1.95. What is the ratio of the Expenditure(as % of GDP) of Russian Federation in 2003 to that in 2011?
Offer a very short reply. 1.18. What is the ratio of the Expenditure(as % of GDP) of Colombia in 2004 to that in 2005?
Provide a succinct answer. 1.01. What is the ratio of the Expenditure(as % of GDP) of Montenegro in 2004 to that in 2005?
Your response must be concise. 1.1. What is the ratio of the Expenditure(as % of GDP) in Russian Federation in 2004 to that in 2005?
Give a very brief answer. 1.08. What is the ratio of the Expenditure(as % of GDP) in European Union in 2004 to that in 2006?
Your response must be concise. 0.99. What is the ratio of the Expenditure(as % of GDP) of Colombia in 2004 to that in 2006?
Offer a very short reply. 1.02. What is the ratio of the Expenditure(as % of GDP) of Montenegro in 2004 to that in 2006?
Keep it short and to the point. 0.82. What is the ratio of the Expenditure(as % of GDP) of Russian Federation in 2004 to that in 2006?
Provide a short and direct response. 1.07. What is the ratio of the Expenditure(as % of GDP) of European Union in 2004 to that in 2007?
Provide a succinct answer. 0.99. What is the ratio of the Expenditure(as % of GDP) of Colombia in 2004 to that in 2007?
Provide a short and direct response. 0.89. What is the ratio of the Expenditure(as % of GDP) of Montenegro in 2004 to that in 2007?
Offer a very short reply. 0.89. What is the ratio of the Expenditure(as % of GDP) in Russian Federation in 2004 to that in 2007?
Ensure brevity in your answer.  1.03. What is the ratio of the Expenditure(as % of GDP) of European Union in 2004 to that in 2011?
Ensure brevity in your answer.  0.89. What is the ratio of the Expenditure(as % of GDP) in Colombia in 2004 to that in 2011?
Provide a short and direct response. 0.81. What is the ratio of the Expenditure(as % of GDP) of Montenegro in 2004 to that in 2011?
Ensure brevity in your answer.  2.49. What is the ratio of the Expenditure(as % of GDP) of Russian Federation in 2004 to that in 2011?
Make the answer very short. 1.06. What is the ratio of the Expenditure(as % of GDP) in Colombia in 2005 to that in 2006?
Ensure brevity in your answer.  1.01. What is the ratio of the Expenditure(as % of GDP) of Montenegro in 2005 to that in 2006?
Provide a short and direct response. 0.74. What is the ratio of the Expenditure(as % of GDP) of Russian Federation in 2005 to that in 2006?
Make the answer very short. 1. What is the ratio of the Expenditure(as % of GDP) of European Union in 2005 to that in 2007?
Your answer should be compact. 0.99. What is the ratio of the Expenditure(as % of GDP) of Colombia in 2005 to that in 2007?
Your answer should be compact. 0.88. What is the ratio of the Expenditure(as % of GDP) in Montenegro in 2005 to that in 2007?
Your answer should be very brief. 0.8. What is the ratio of the Expenditure(as % of GDP) in Russian Federation in 2005 to that in 2007?
Provide a succinct answer. 0.96. What is the ratio of the Expenditure(as % of GDP) of European Union in 2005 to that in 2011?
Make the answer very short. 0.89. What is the ratio of the Expenditure(as % of GDP) in Colombia in 2005 to that in 2011?
Make the answer very short. 0.8. What is the ratio of the Expenditure(as % of GDP) of Montenegro in 2005 to that in 2011?
Your response must be concise. 2.26. What is the ratio of the Expenditure(as % of GDP) in Russian Federation in 2005 to that in 2011?
Ensure brevity in your answer.  0.98. What is the ratio of the Expenditure(as % of GDP) in European Union in 2006 to that in 2007?
Your answer should be compact. 1. What is the ratio of the Expenditure(as % of GDP) of Colombia in 2006 to that in 2007?
Provide a short and direct response. 0.87. What is the ratio of the Expenditure(as % of GDP) in Montenegro in 2006 to that in 2007?
Provide a succinct answer. 1.08. What is the ratio of the Expenditure(as % of GDP) of Russian Federation in 2006 to that in 2007?
Provide a short and direct response. 0.96. What is the ratio of the Expenditure(as % of GDP) in European Union in 2006 to that in 2011?
Offer a very short reply. 0.9. What is the ratio of the Expenditure(as % of GDP) in Colombia in 2006 to that in 2011?
Offer a terse response. 0.8. What is the ratio of the Expenditure(as % of GDP) in Montenegro in 2006 to that in 2011?
Keep it short and to the point. 3.04. What is the ratio of the Expenditure(as % of GDP) in Russian Federation in 2006 to that in 2011?
Provide a succinct answer. 0.98. What is the ratio of the Expenditure(as % of GDP) in European Union in 2007 to that in 2011?
Your response must be concise. 0.9. What is the ratio of the Expenditure(as % of GDP) in Colombia in 2007 to that in 2011?
Provide a short and direct response. 0.92. What is the ratio of the Expenditure(as % of GDP) of Montenegro in 2007 to that in 2011?
Offer a terse response. 2.81. What is the ratio of the Expenditure(as % of GDP) in Russian Federation in 2007 to that in 2011?
Provide a succinct answer. 1.02. What is the difference between the highest and the second highest Expenditure(as % of GDP) in European Union?
Give a very brief answer. 0.17. What is the difference between the highest and the second highest Expenditure(as % of GDP) in Colombia?
Your answer should be compact. 0.02. What is the difference between the highest and the second highest Expenditure(as % of GDP) of Montenegro?
Your response must be concise. 0.09. What is the difference between the highest and the second highest Expenditure(as % of GDP) of Russian Federation?
Provide a succinct answer. 0.13. What is the difference between the highest and the lowest Expenditure(as % of GDP) in European Union?
Give a very brief answer. 0.21. What is the difference between the highest and the lowest Expenditure(as % of GDP) in Colombia?
Make the answer very short. 0.04. What is the difference between the highest and the lowest Expenditure(as % of GDP) of Montenegro?
Your answer should be compact. 0.83. What is the difference between the highest and the lowest Expenditure(as % of GDP) in Russian Federation?
Your answer should be compact. 0.22. 